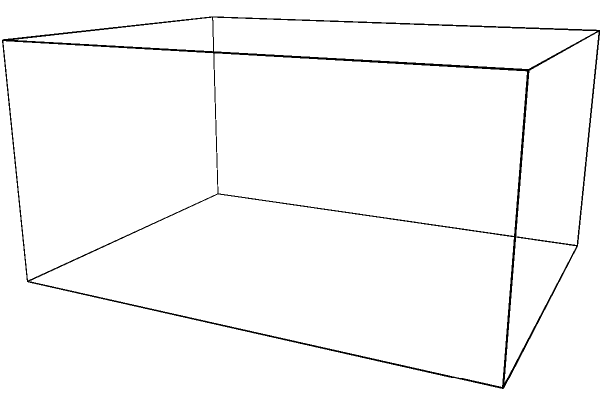As the city planner turned PR officer for Winnipeg, you're tasked with presenting the most efficient shape for a new multi-story parking garage. Given that both a rectangular prism and a cylindrical shape are being considered, which would maximize capacity while minimizing land use? Assume both shapes have the same height and volume. Explain your reasoning using solid geometry principles. To determine the most efficient shape, we need to compare the surface area-to-volume ratios of both shapes, as this will indicate which shape provides more usable space (volume) with less land use (base area).

1. For a rectangular prism:
   - Volume: $V_r = l \times w \times h$
   - Base Area: $A_r = l \times w$
   - Surface Area: $SA_r = 2(lw + lh + wh)$

2. For a cylinder:
   - Volume: $V_c = \pi r^2 h$
   - Base Area: $A_c = \pi r^2$
   - Surface Area: $SA_c = 2\pi r^2 + 2\pi rh$

3. Given that both shapes have the same volume and height, we can set:
   $l \times w \times h = \pi r^2 h$

4. Simplifying:
   $lw = \pi r^2$

5. This means the base area of the cylinder is always smaller than the rectangular prism for the same volume.

6. For the surface area, the cylinder will generally have less surface area than the rectangular prism due to its curved sides, which eliminates the need for corners.

7. The cylinder's circular base also provides better traffic flow for vehicles, reducing wasted space on sharp turns.

Therefore, the cylindrical shape is more efficient in maximizing capacity while minimizing land use. It provides the same volume with a smaller footprint and generally less surface area, making it the optimal choice for a multi-story parking garage in urban planning.
Answer: Cylindrical shape 